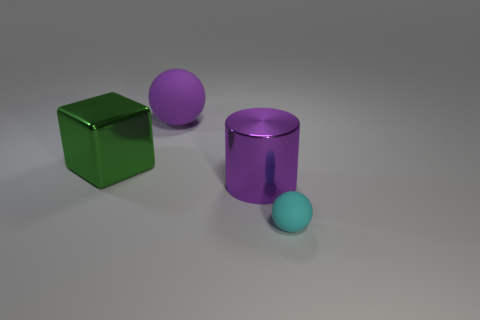Is there a big sphere that is behind the purple object that is in front of the large purple thing that is behind the green cube?
Offer a terse response. Yes. What shape is the other metal thing that is the same size as the green metal thing?
Offer a terse response. Cylinder. There is another thing that is the same shape as the tiny cyan thing; what is its color?
Offer a terse response. Purple. What number of things are either large purple rubber things or tiny gray spheres?
Give a very brief answer. 1. Does the matte thing that is in front of the big sphere have the same shape as the purple thing that is behind the green metal thing?
Provide a succinct answer. Yes. What is the shape of the big purple object that is behind the large metallic cube?
Make the answer very short. Sphere. Are there an equal number of purple cylinders behind the small cyan rubber thing and small matte balls to the left of the big green metal object?
Your answer should be very brief. No. How many things are matte balls or things that are in front of the large cube?
Offer a terse response. 3. The thing that is both in front of the big rubber sphere and to the left of the cylinder has what shape?
Ensure brevity in your answer.  Cube. What is the purple object that is in front of the sphere that is on the left side of the cyan matte sphere made of?
Ensure brevity in your answer.  Metal. 